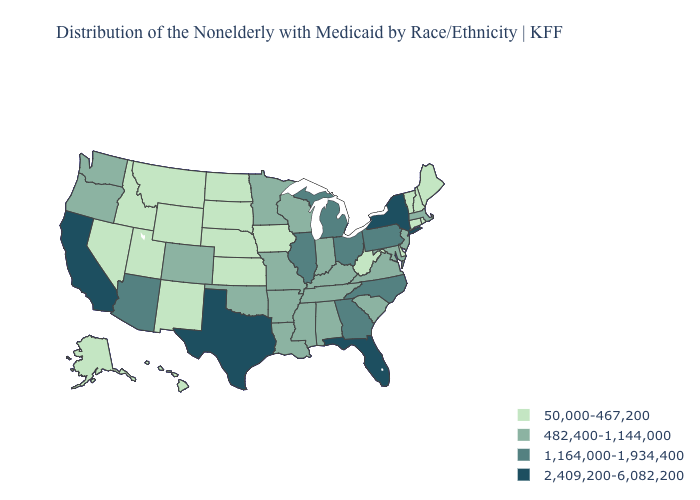Name the states that have a value in the range 1,164,000-1,934,400?
Concise answer only. Arizona, Georgia, Illinois, Michigan, North Carolina, Ohio, Pennsylvania. Is the legend a continuous bar?
Answer briefly. No. Name the states that have a value in the range 1,164,000-1,934,400?
Keep it brief. Arizona, Georgia, Illinois, Michigan, North Carolina, Ohio, Pennsylvania. What is the highest value in states that border North Carolina?
Short answer required. 1,164,000-1,934,400. Name the states that have a value in the range 1,164,000-1,934,400?
Short answer required. Arizona, Georgia, Illinois, Michigan, North Carolina, Ohio, Pennsylvania. What is the value of New Hampshire?
Answer briefly. 50,000-467,200. Name the states that have a value in the range 2,409,200-6,082,200?
Concise answer only. California, Florida, New York, Texas. Name the states that have a value in the range 50,000-467,200?
Write a very short answer. Alaska, Connecticut, Delaware, Hawaii, Idaho, Iowa, Kansas, Maine, Montana, Nebraska, Nevada, New Hampshire, New Mexico, North Dakota, Rhode Island, South Dakota, Utah, Vermont, West Virginia, Wyoming. Name the states that have a value in the range 1,164,000-1,934,400?
Answer briefly. Arizona, Georgia, Illinois, Michigan, North Carolina, Ohio, Pennsylvania. What is the value of Nevada?
Answer briefly. 50,000-467,200. Name the states that have a value in the range 50,000-467,200?
Give a very brief answer. Alaska, Connecticut, Delaware, Hawaii, Idaho, Iowa, Kansas, Maine, Montana, Nebraska, Nevada, New Hampshire, New Mexico, North Dakota, Rhode Island, South Dakota, Utah, Vermont, West Virginia, Wyoming. Does the map have missing data?
Quick response, please. No. Does New York have the highest value in the Northeast?
Write a very short answer. Yes. Which states have the highest value in the USA?
Quick response, please. California, Florida, New York, Texas. 